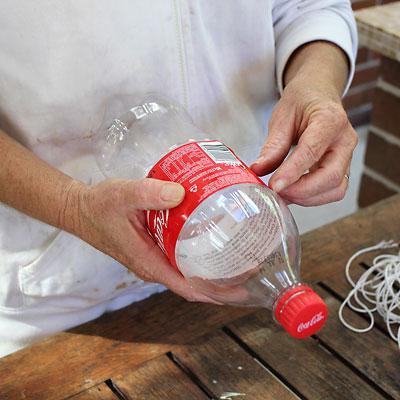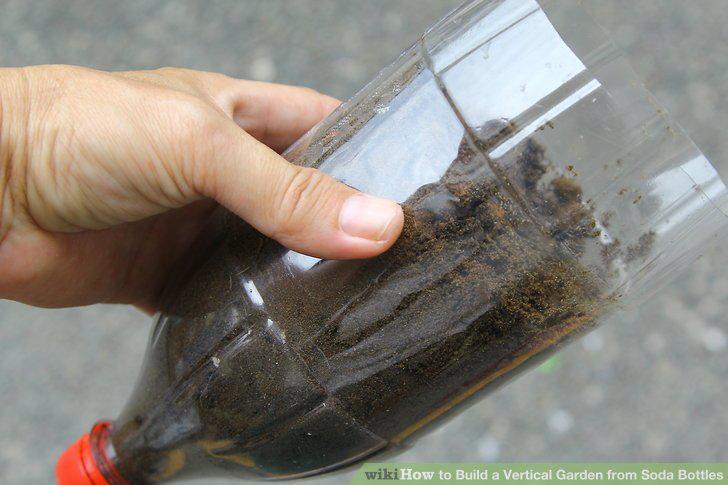The first image is the image on the left, the second image is the image on the right. Examine the images to the left and right. Is the description "The bottles in one of the images are attached to a wall as planters." accurate? Answer yes or no. No. 